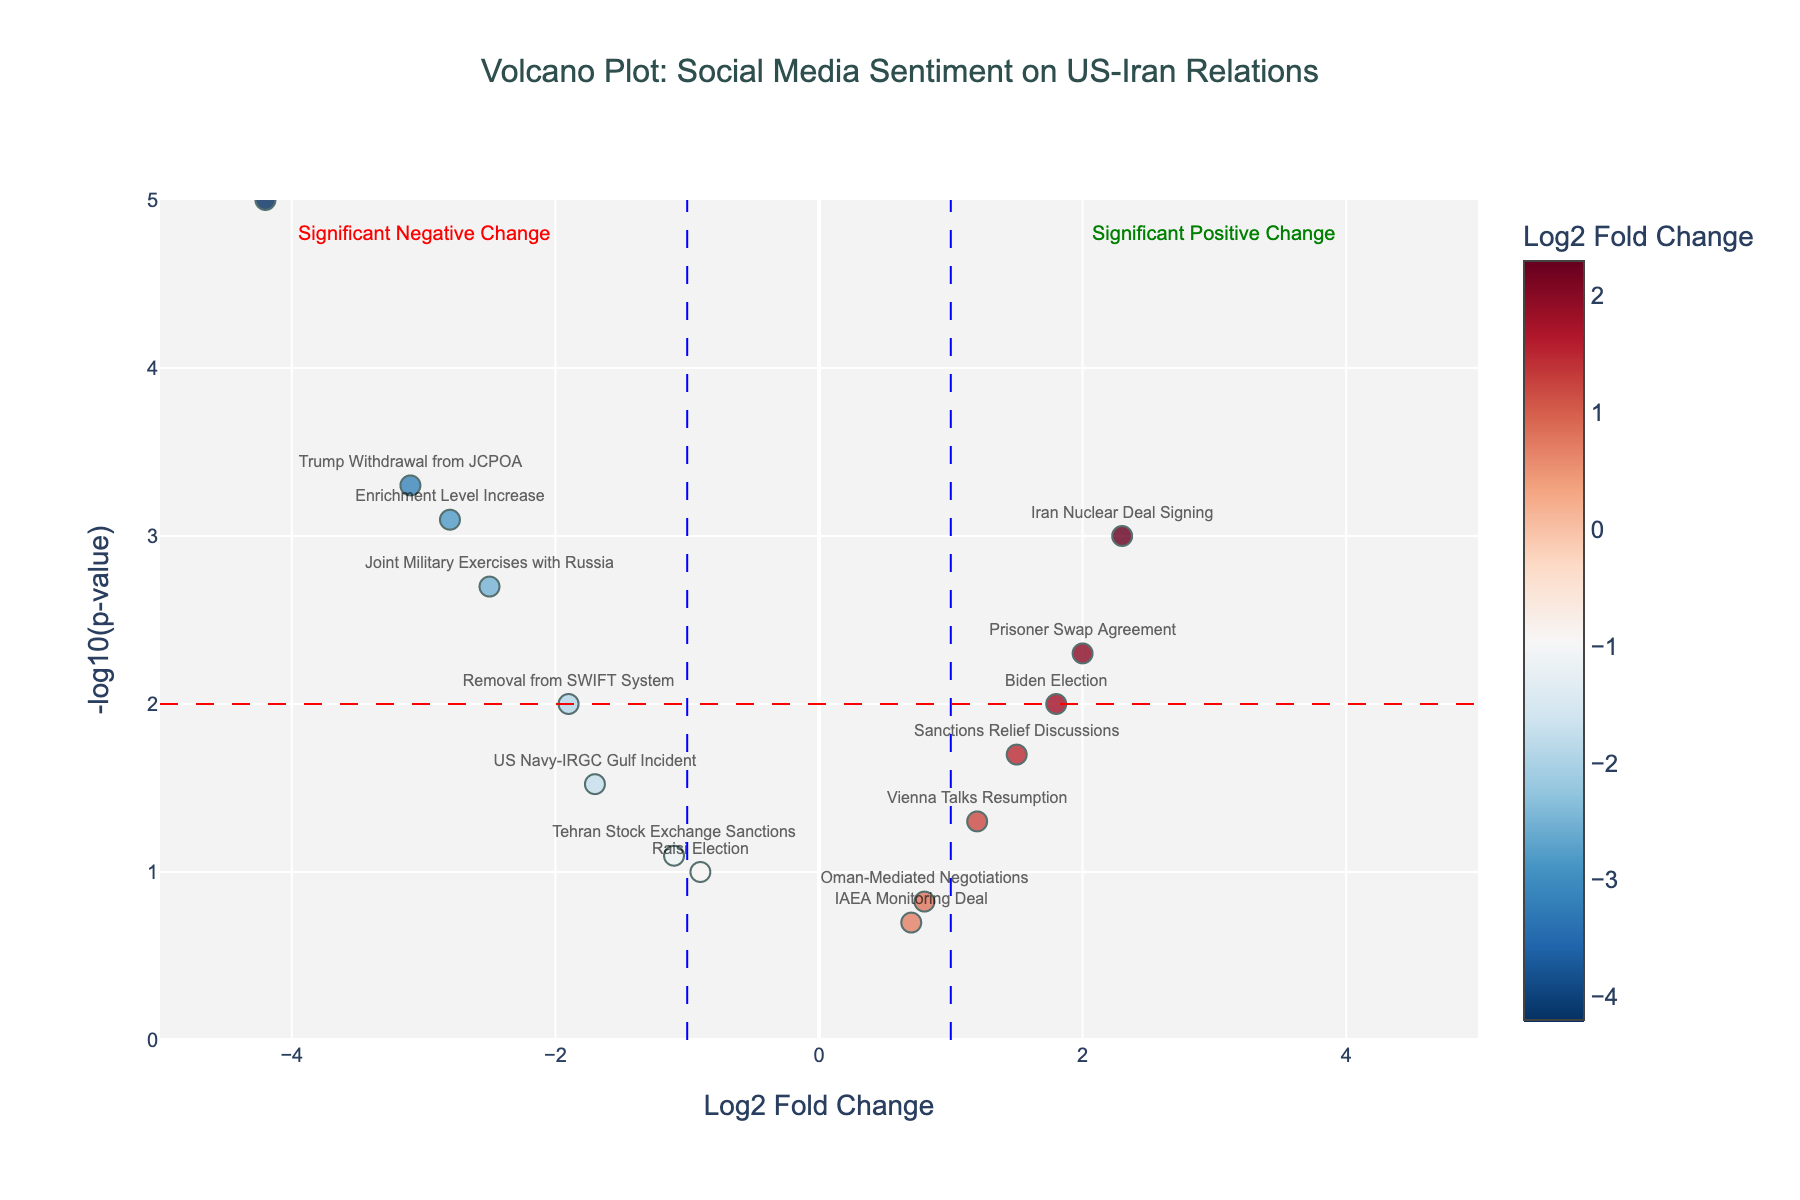What is the title of the plot? The title is located at the top center of the plot, and it reads "Volcano Plot: Social Media Sentiment on US-Iran Relations".
Answer: "Volcano Plot: Social Media Sentiment on US-Iran Relations" What do the x and y axes represent? The x-axis represents the Log2 Fold Change, while the y-axis represents the -log10(p-value). These are standard axes for a volcano plot.
Answer: Log2 Fold Change and -log10(p-value) How many events show a significant negative change in sentiment? A significant change is indicated by a point beyond the dashed lines at -1 or 1 on the x-axis and above 2 on the y-axis. There are four events in the negative region beyond these thresholds.
Answer: Four events Which event has the most negative sentiment change, and what is its Log2 Fold Change and p-value? The event with the most negative sentiment change is identified by the lowest position on the x-axis. It is "Soleimani Assassination" with a Log2 Fold Change of -4.2 and a p-value of 0.00001.
Answer: Soleimani Assassination, -4.2, 0.00001 Which event has the most positive sentiment change and what are its values for Log2 Fold Change and p-value? The event with the most positive sentiment change is found at the highest position on the x-axis. It is "Iran Nuclear Deal Signing" with a Log2 Fold Change of 2.3 and a p-value of 0.001.
Answer: Iran Nuclear Deal Signing, 2.3, 0.001 How is significance represented in this plot? Significance is depicted by threshold lines: red dashed line at y=2 indicating -log10(p-value) significance and blue dashed lines at x=1 and x=-1 indicating fold change significance. Points outside these lines are considered significant.
Answer: Thresholds at y=2, x=1, and x=-1 Which event has a Log2 Fold Change closest to zero but is still significant? The "Vienna Talks Resumption" event has a Log2 Fold Change of 1.2, which is closest to zero among significant points. Its p-value is 0.05, barely crossing significance.
Answer: Vienna Talks Resumption, 1.2, 0.05 What is the average Log2 Fold Change for the events that show significant positive changes in sentiment? The events are "Iran Nuclear Deal Signing", "Biden Election", "Sanctions Relief Discussions", and "Prisoner Swap Agreement" with Log2 Fold Changes of 2.3, 1.8, 1.5, and 2.0 respectively. The average is (2.3 + 1.8 + 1.5 + 2.0) / 4 = 1.9.
Answer: 1.9 